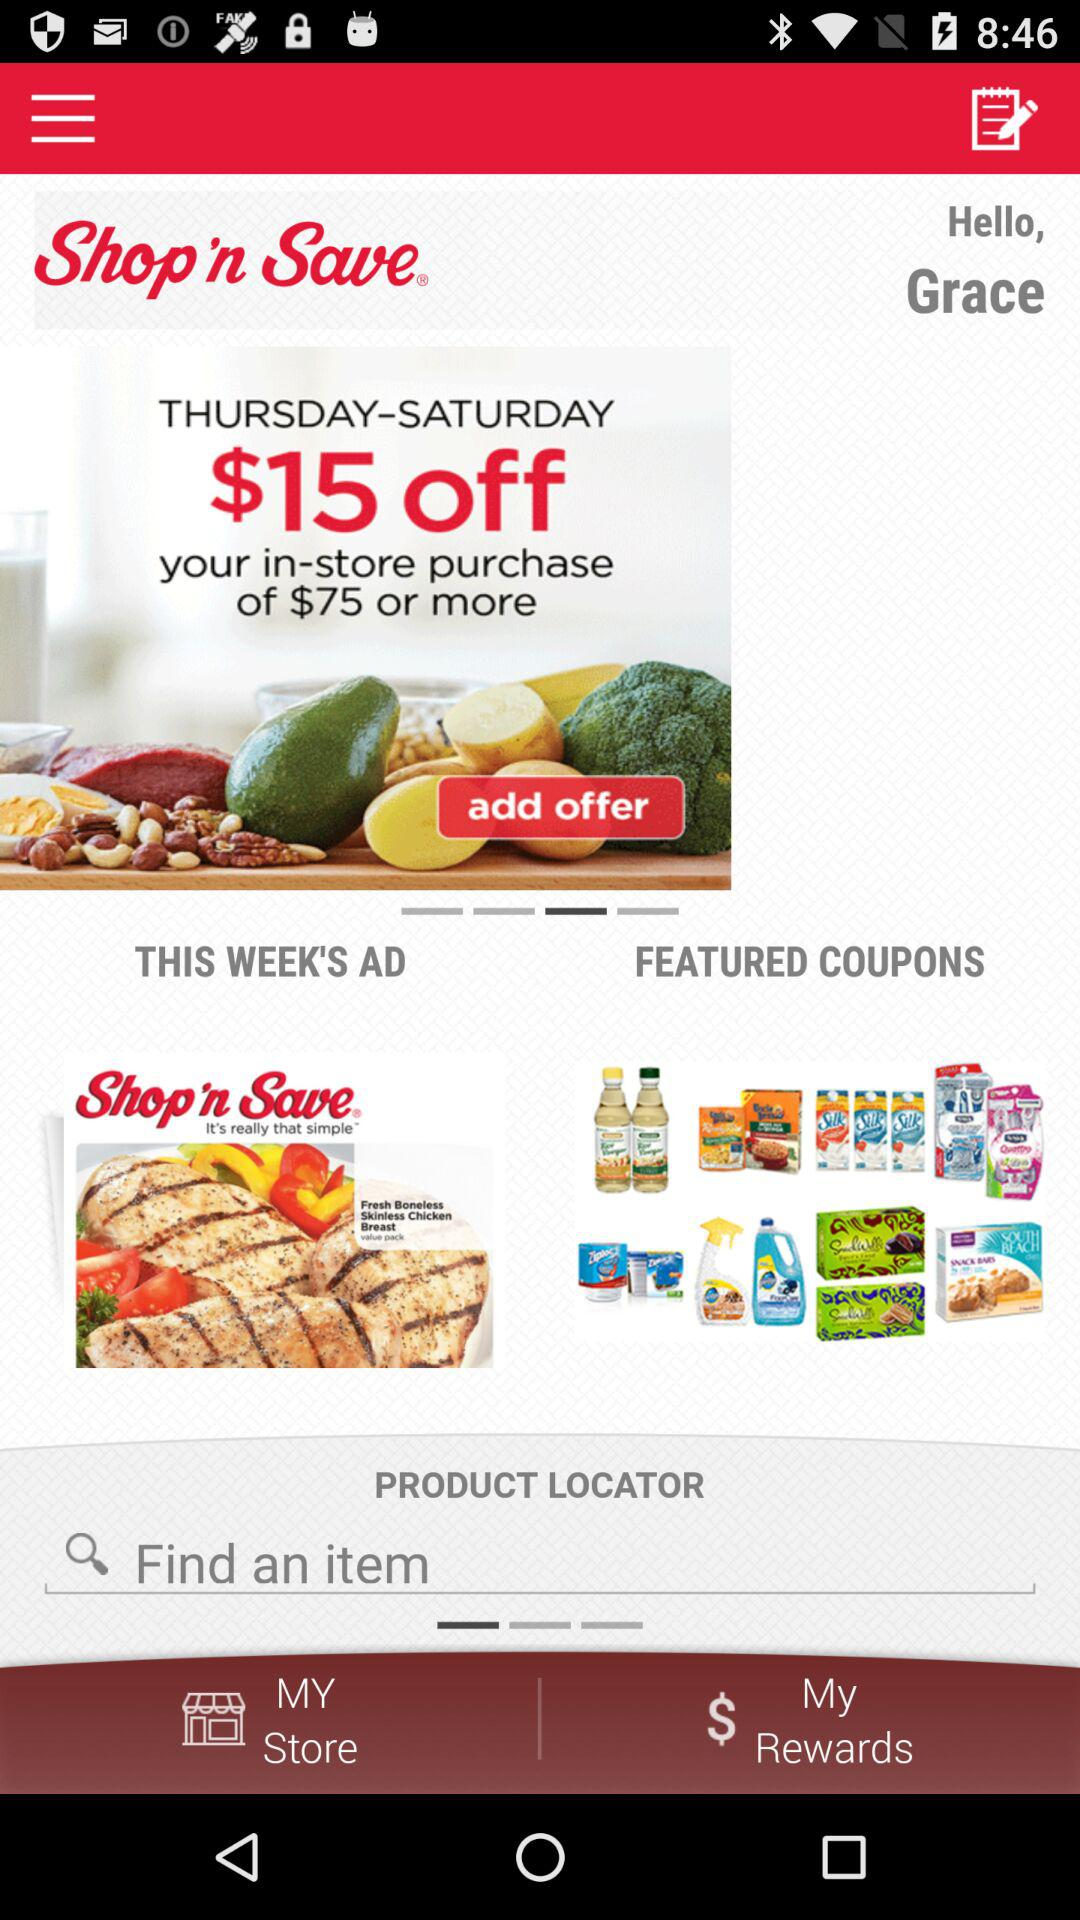On which days is there a $15 discount? There is a $15 discount on Thursday, Friday and Saturday. 